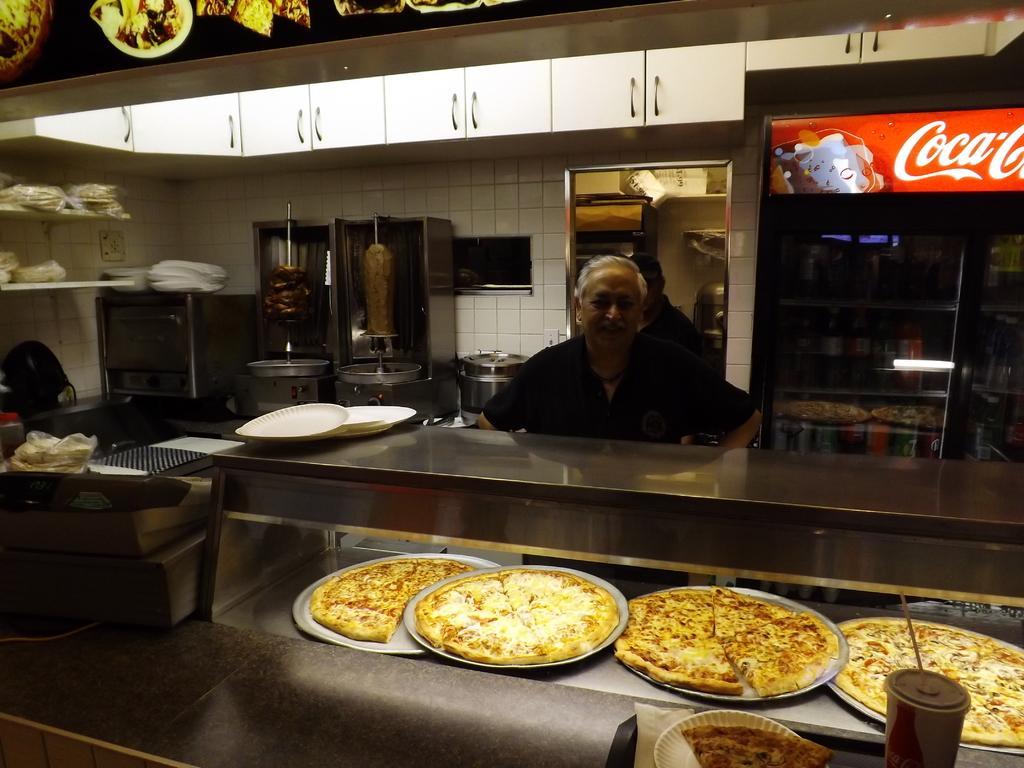In one or two sentences, can you explain what this image depicts? In this picture we can see pizzas in the plates and a cup and we can see a man in front of the table, besides to him we can see a refrigerator, behind to him we can see some machine equipments and plates. 